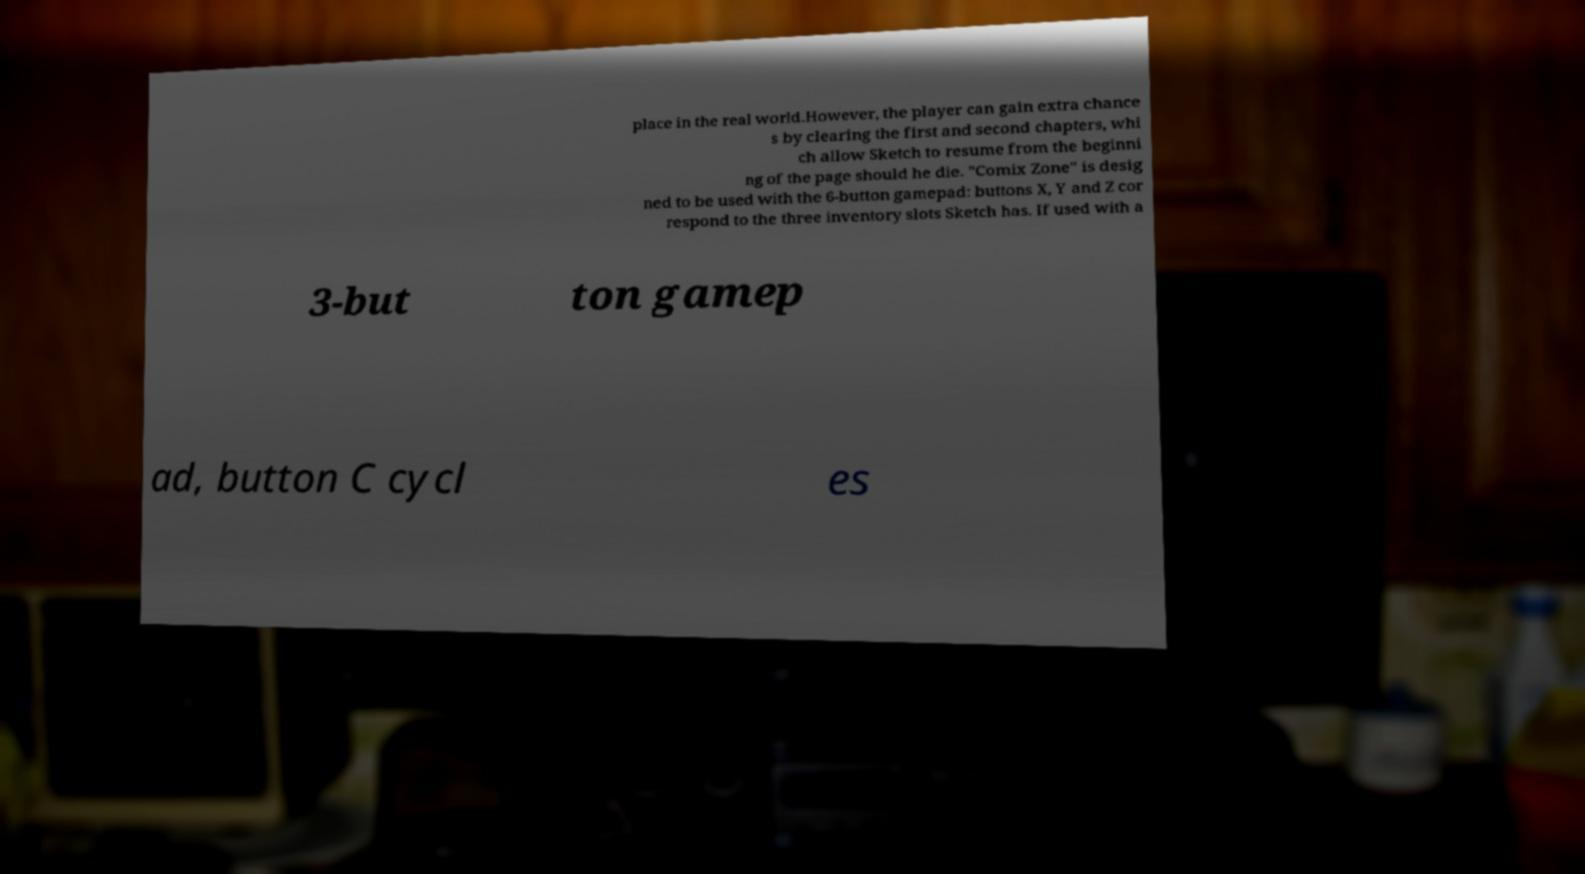Please identify and transcribe the text found in this image. place in the real world.However, the player can gain extra chance s by clearing the first and second chapters, whi ch allow Sketch to resume from the beginni ng of the page should he die. "Comix Zone" is desig ned to be used with the 6-button gamepad: buttons X, Y and Z cor respond to the three inventory slots Sketch has. If used with a 3-but ton gamep ad, button C cycl es 